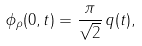Convert formula to latex. <formula><loc_0><loc_0><loc_500><loc_500>\phi _ { \rho } ( 0 , t ) = \frac { \pi } { \sqrt { 2 } } \, q ( t ) ,</formula> 